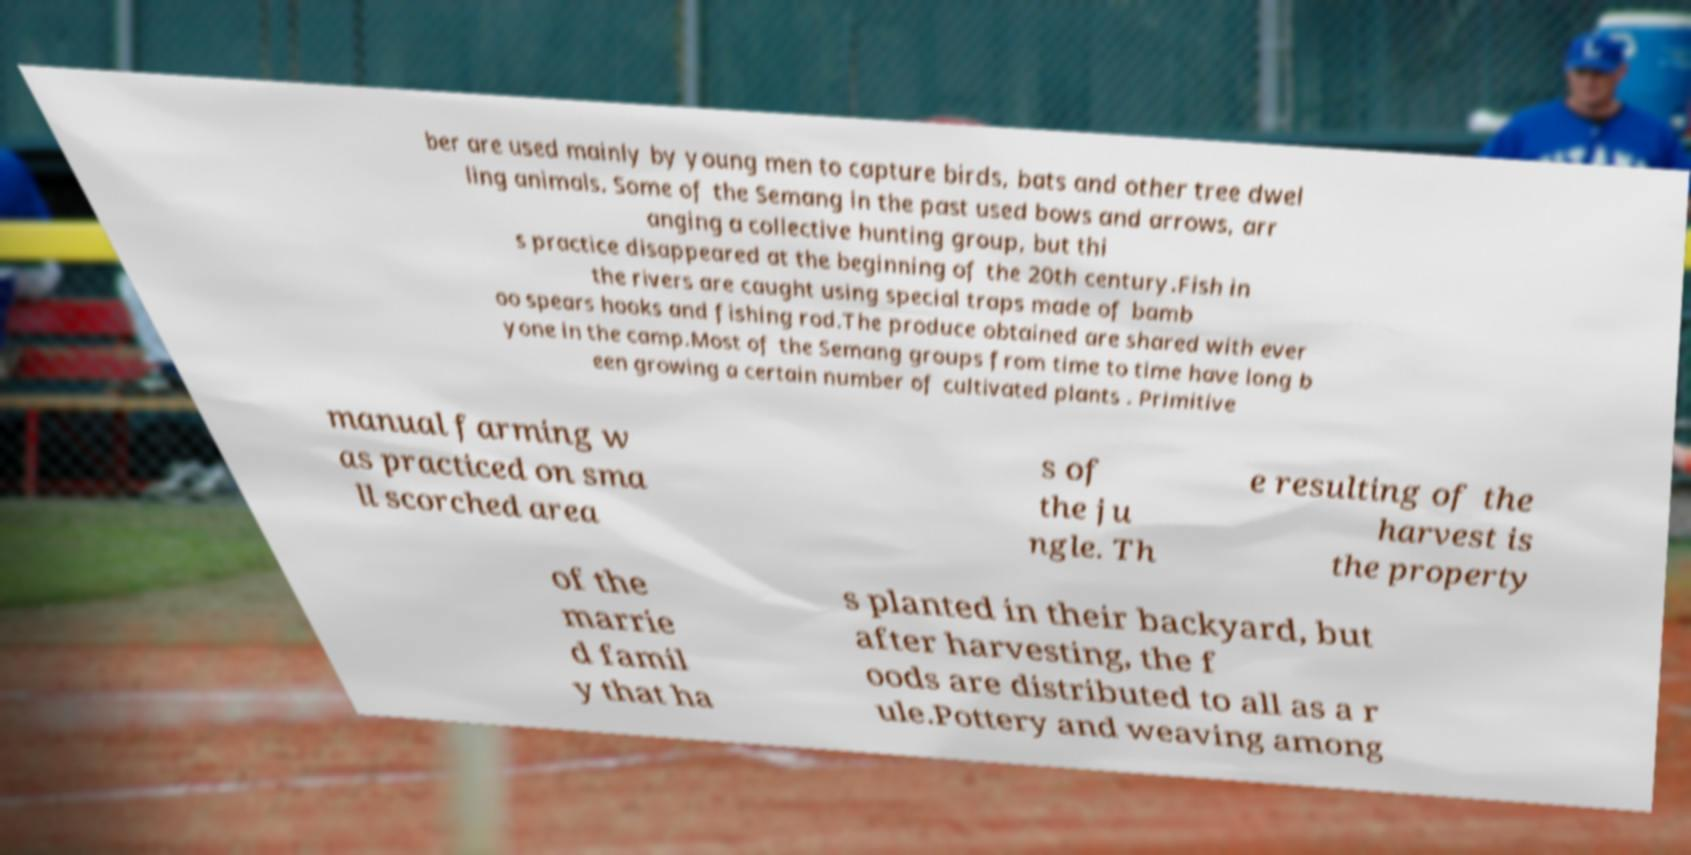I need the written content from this picture converted into text. Can you do that? ber are used mainly by young men to capture birds, bats and other tree dwel ling animals. Some of the Semang in the past used bows and arrows, arr anging a collective hunting group, but thi s practice disappeared at the beginning of the 20th century.Fish in the rivers are caught using special traps made of bamb oo spears hooks and fishing rod.The produce obtained are shared with ever yone in the camp.Most of the Semang groups from time to time have long b een growing a certain number of cultivated plants . Primitive manual farming w as practiced on sma ll scorched area s of the ju ngle. Th e resulting of the harvest is the property of the marrie d famil y that ha s planted in their backyard, but after harvesting, the f oods are distributed to all as a r ule.Pottery and weaving among 